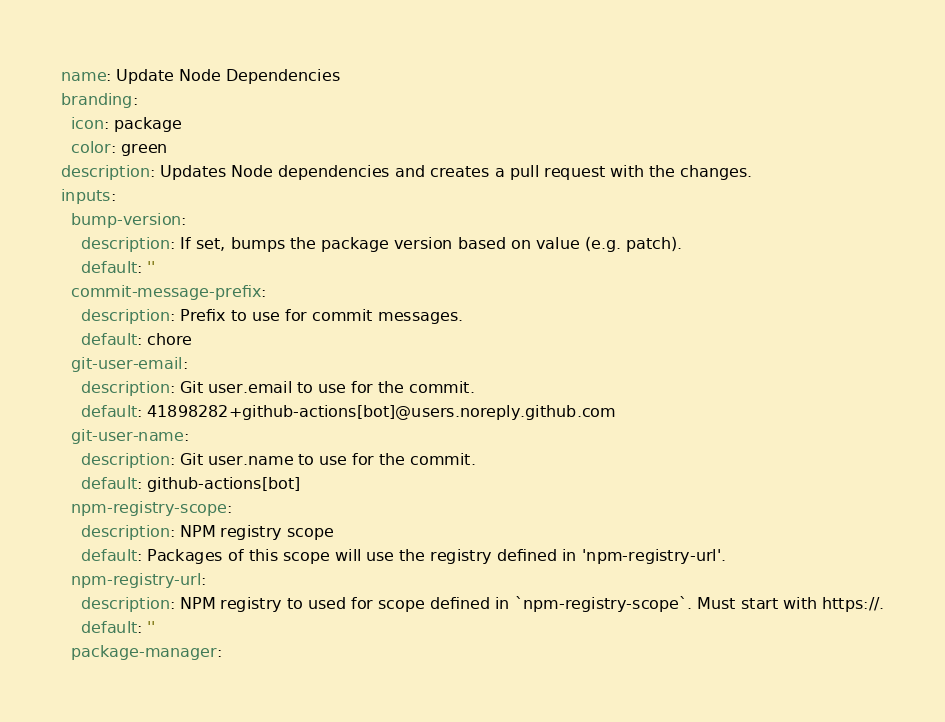<code> <loc_0><loc_0><loc_500><loc_500><_YAML_>name: Update Node Dependencies
branding:
  icon: package
  color: green
description: Updates Node dependencies and creates a pull request with the changes.
inputs:
  bump-version:
    description: If set, bumps the package version based on value (e.g. patch).
    default: ''
  commit-message-prefix:
    description: Prefix to use for commit messages.
    default: chore
  git-user-email:
    description: Git user.email to use for the commit.
    default: 41898282+github-actions[bot]@users.noreply.github.com
  git-user-name:
    description: Git user.name to use for the commit.
    default: github-actions[bot]
  npm-registry-scope:
    description: NPM registry scope
    default: Packages of this scope will use the registry defined in 'npm-registry-url'.
  npm-registry-url:
    description: NPM registry to used for scope defined in `npm-registry-scope`. Must start with https://.
    default: ''
  package-manager:</code> 